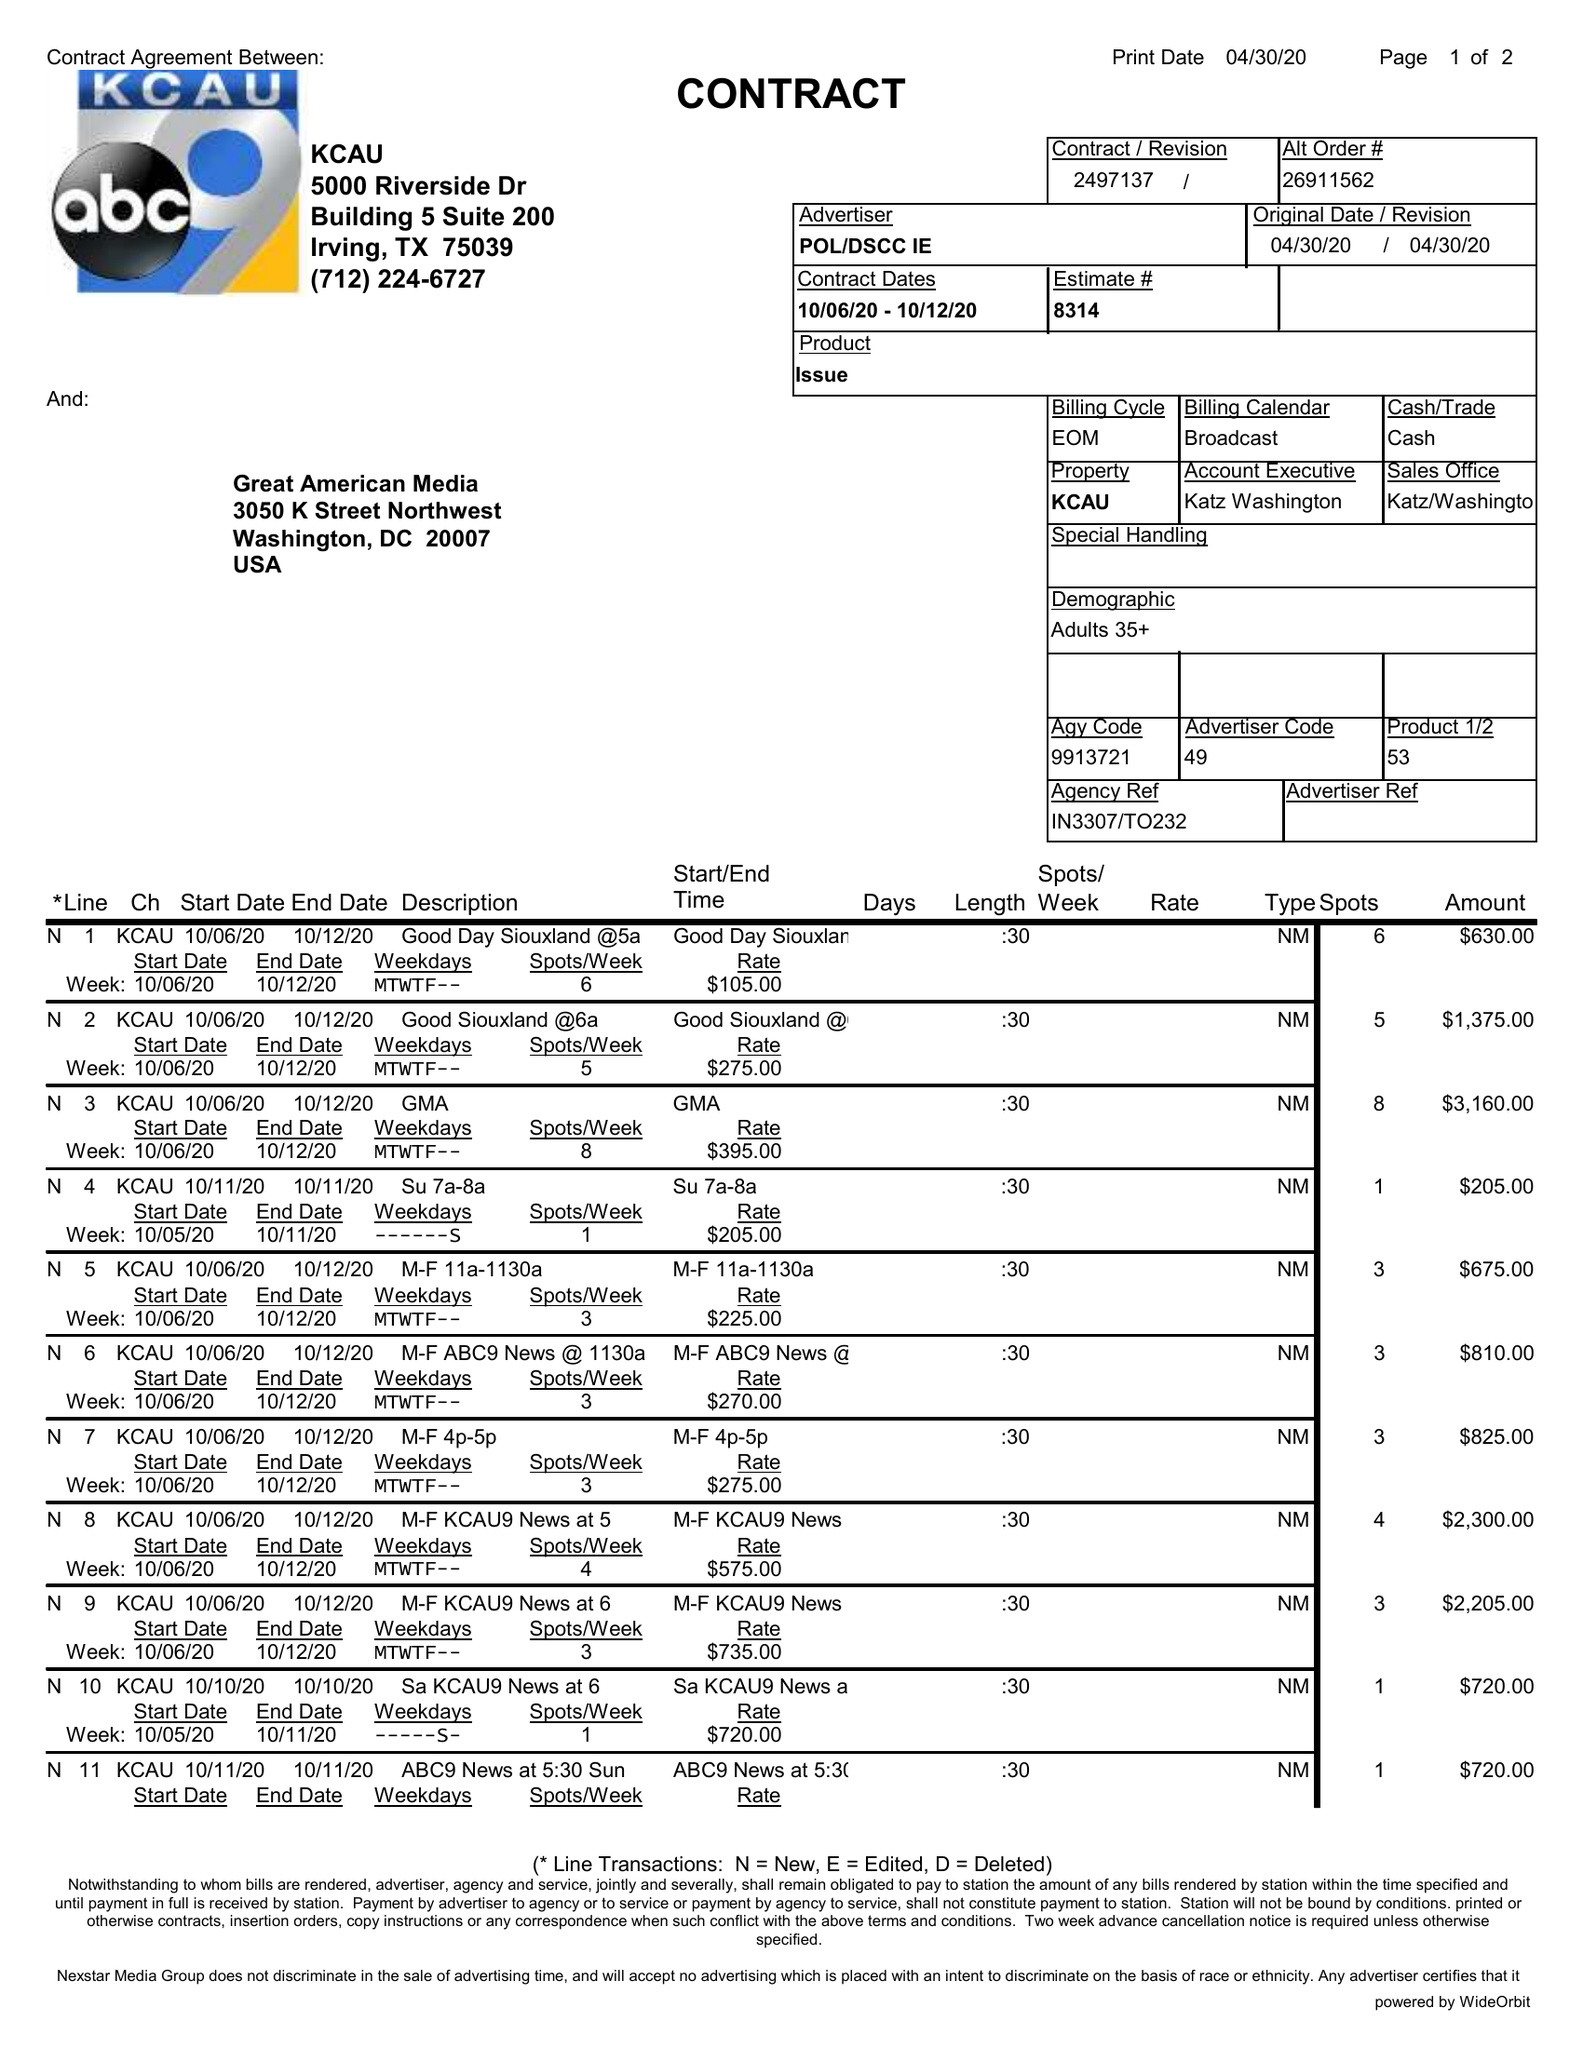What is the value for the flight_from?
Answer the question using a single word or phrase. 10/06/20 